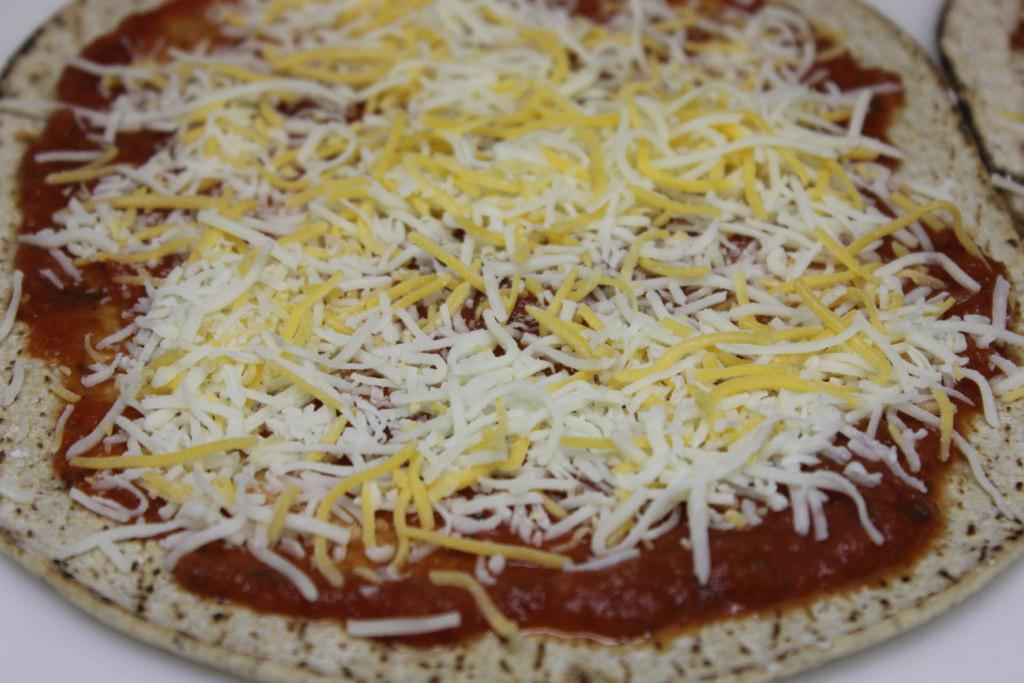What is the main subject in the foreground of the image? There is a pizza in the foreground of the image. Can you describe the pizza in more detail? Yes, there is cheese on the pizza. What type of rod can be seen holding the pizza in the image? There is no rod present in the image; the pizza is not being held by any such object. What sound does the whistle make in the image? There is no whistle present in the image, so it cannot make any sound. 